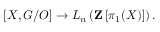Convert formula to latex. <formula><loc_0><loc_0><loc_500><loc_500>[ X , G / O ] \to L _ { n } \left ( Z \left [ \pi _ { 1 } ( X ) \right ] \right ) .</formula> 